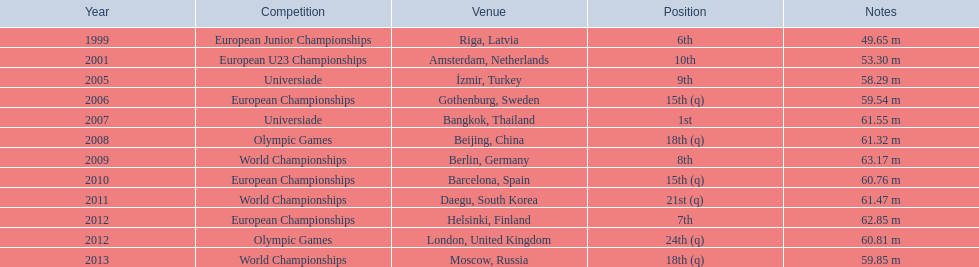Parse the table in full. {'header': ['Year', 'Competition', 'Venue', 'Position', 'Notes'], 'rows': [['1999', 'European Junior Championships', 'Riga, Latvia', '6th', '49.65 m'], ['2001', 'European U23 Championships', 'Amsterdam, Netherlands', '10th', '53.30 m'], ['2005', 'Universiade', 'İzmir, Turkey', '9th', '58.29 m'], ['2006', 'European Championships', 'Gothenburg, Sweden', '15th (q)', '59.54 m'], ['2007', 'Universiade', 'Bangkok, Thailand', '1st', '61.55 m'], ['2008', 'Olympic Games', 'Beijing, China', '18th (q)', '61.32 m'], ['2009', 'World Championships', 'Berlin, Germany', '8th', '63.17 m'], ['2010', 'European Championships', 'Barcelona, Spain', '15th (q)', '60.76 m'], ['2011', 'World Championships', 'Daegu, South Korea', '21st (q)', '61.47 m'], ['2012', 'European Championships', 'Helsinki, Finland', '7th', '62.85 m'], ['2012', 'Olympic Games', 'London, United Kingdom', '24th (q)', '60.81 m'], ['2013', 'World Championships', 'Moscow, Russia', '18th (q)', '59.85 m']]} How what listed year was a distance of only 53.30m reached? 2001. 